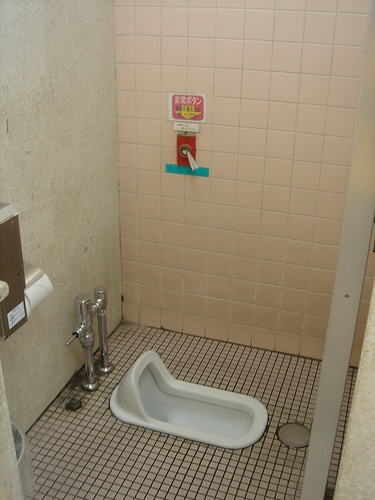Describe the objects in this image and their specific colors. I can see a toilet in darkgray and gray tones in this image. 